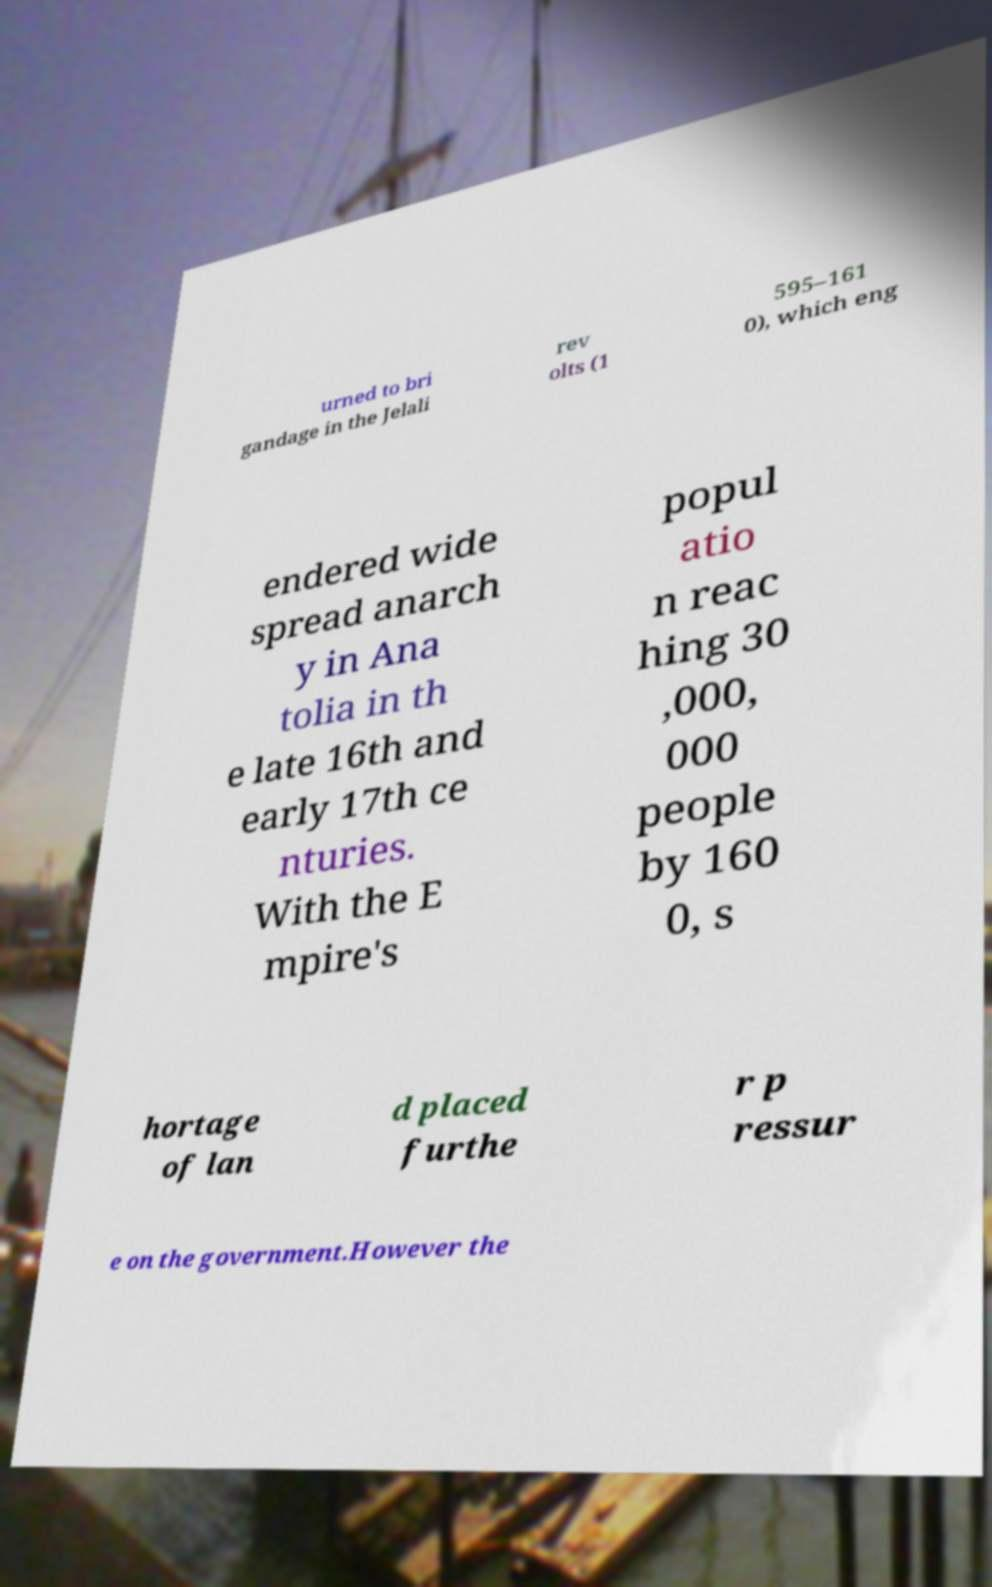There's text embedded in this image that I need extracted. Can you transcribe it verbatim? urned to bri gandage in the Jelali rev olts (1 595–161 0), which eng endered wide spread anarch y in Ana tolia in th e late 16th and early 17th ce nturies. With the E mpire's popul atio n reac hing 30 ,000, 000 people by 160 0, s hortage of lan d placed furthe r p ressur e on the government.However the 